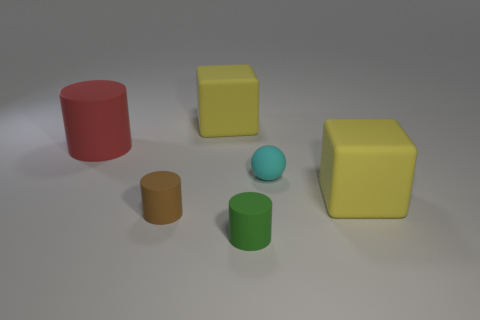What color is the matte sphere that is the same size as the brown object?
Offer a very short reply. Cyan. There is a yellow block behind the red rubber object; what is its size?
Make the answer very short. Large. Are there any rubber cylinders left of the thing behind the big red cylinder?
Your answer should be compact. Yes. Does the yellow block that is to the right of the tiny green object have the same material as the green thing?
Your response must be concise. Yes. What number of big objects are both in front of the big cylinder and behind the red thing?
Your response must be concise. 0. How many big green blocks have the same material as the green cylinder?
Offer a terse response. 0. What is the color of the ball that is the same material as the big cylinder?
Your response must be concise. Cyan. Is the number of gray objects less than the number of big red objects?
Provide a short and direct response. Yes. There is a block that is in front of the large red cylinder; is it the same color as the matte block to the left of the tiny cyan matte thing?
Your answer should be compact. Yes. Is the number of gray metallic cylinders greater than the number of green cylinders?
Offer a very short reply. No. 